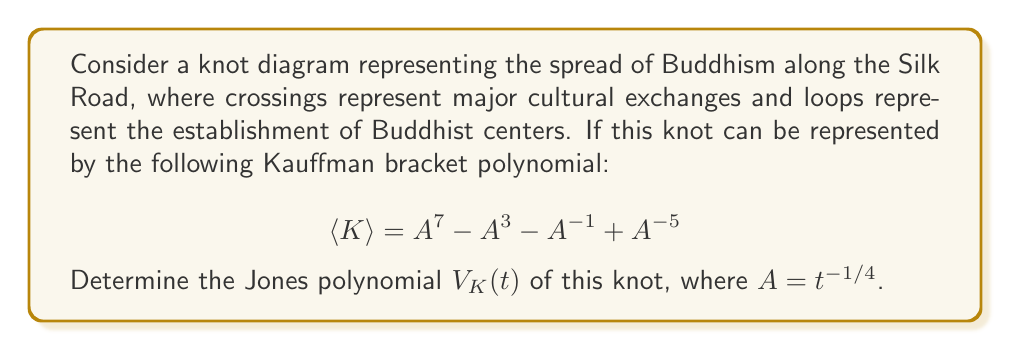Give your solution to this math problem. To find the Jones polynomial from the Kauffman bracket polynomial, we follow these steps:

1) First, recall that the Jones polynomial $V_K(t)$ is related to the Kauffman bracket polynomial $\langle K \rangle$ by:

   $$V_K(t) = (-A^3)^{-w(K)} \langle K \rangle$$

   where $w(K)$ is the writhe of the knot.

2) We're given the Kauffman bracket polynomial:

   $$\langle K \rangle = A^7 - A^3 - A^{-1} + A^{-5}$$

3) We need to determine the writhe $w(K)$. In this case, it's not directly given, but we can deduce it. The highest power of $A$ in the Jones polynomial is typically $-3w(K) + \text{highest power in }\langle K \rangle$. Here, the highest power in $\langle K \rangle$ is 7, so:

   $-3w(K) + 7 = 1$ (as the highest power in a Jones polynomial is usually 1 for a non-trivial knot)
   $-3w(K) = -6$
   $w(K) = 2$

4) Now we can calculate the Jones polynomial:

   $$V_K(t) = (-A^3)^{-2} (A^7 - A^3 - A^{-1} + A^{-5})$$

5) Simplify:

   $$V_K(t) = A^{-6} (A^7 - A^3 - A^{-1} + A^{-5})$$
   $$= A - A^{-3} - A^{-7} + A^{-11}$$

6) Substitute $A = t^{-1/4}$:

   $$V_K(t) = (t^{-1/4})^1 - (t^{-1/4})^{-3} - (t^{-1/4})^{-7} + (t^{-1/4})^{-11}$$
   $$= t^{-1/4} - t^{3/4} - t^{7/4} + t^{11/4}$$

This is the Jones polynomial of the knot representing the spread of Buddhism along the Silk Road.
Answer: $V_K(t) = t^{-1/4} - t^{3/4} - t^{7/4} + t^{11/4}$ 